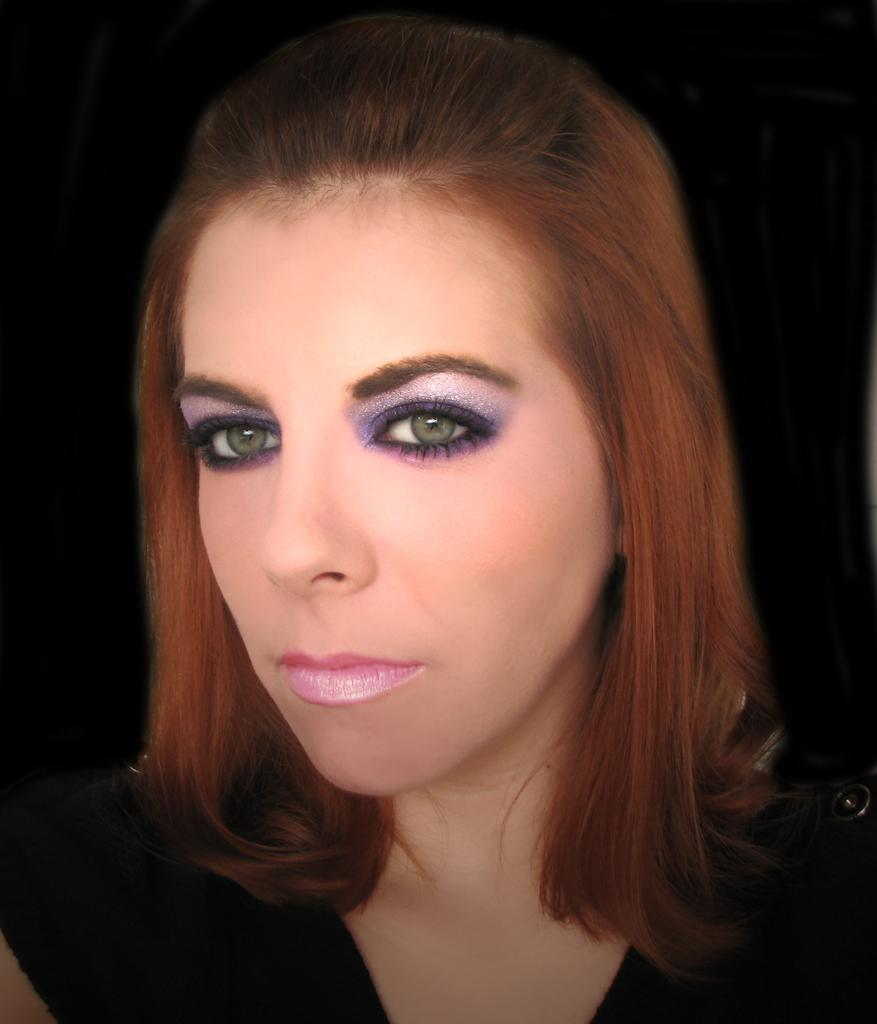Who is the main subject in the picture? There is a woman in the picture. What is the woman wearing in the image? The woman is wearing a black dress. What type of grain is visible in the woman's hair in the image? There is no grain visible in the woman's hair in the image. What kind of creature is sitting on the woman's shoulder in the image? There is no creature present in the image; only the woman wearing a black dress is visible. 